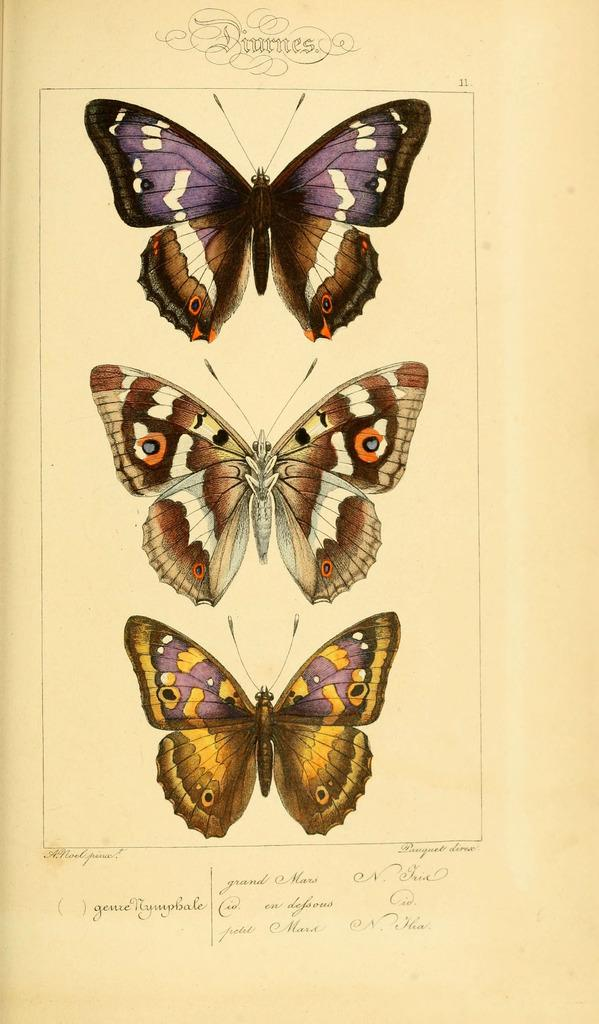What is depicted in the printed images in the picture? There are printed images of butterflies in the picture. How many colors are the butterflies in the picture? The butterflies are of different colors. What is the object with text on it in the picture? The object with text on it seems to be a paper. What type of jelly can be seen in the picture? There is no jelly present in the picture; it features printed images of butterflies and a paper with text. How does the sun affect the butterflies in the picture? The picture does not show the sun or its effects on the butterflies; it only shows printed images of butterflies and a paper with text. 